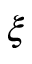Convert formula to latex. <formula><loc_0><loc_0><loc_500><loc_500>\xi</formula> 